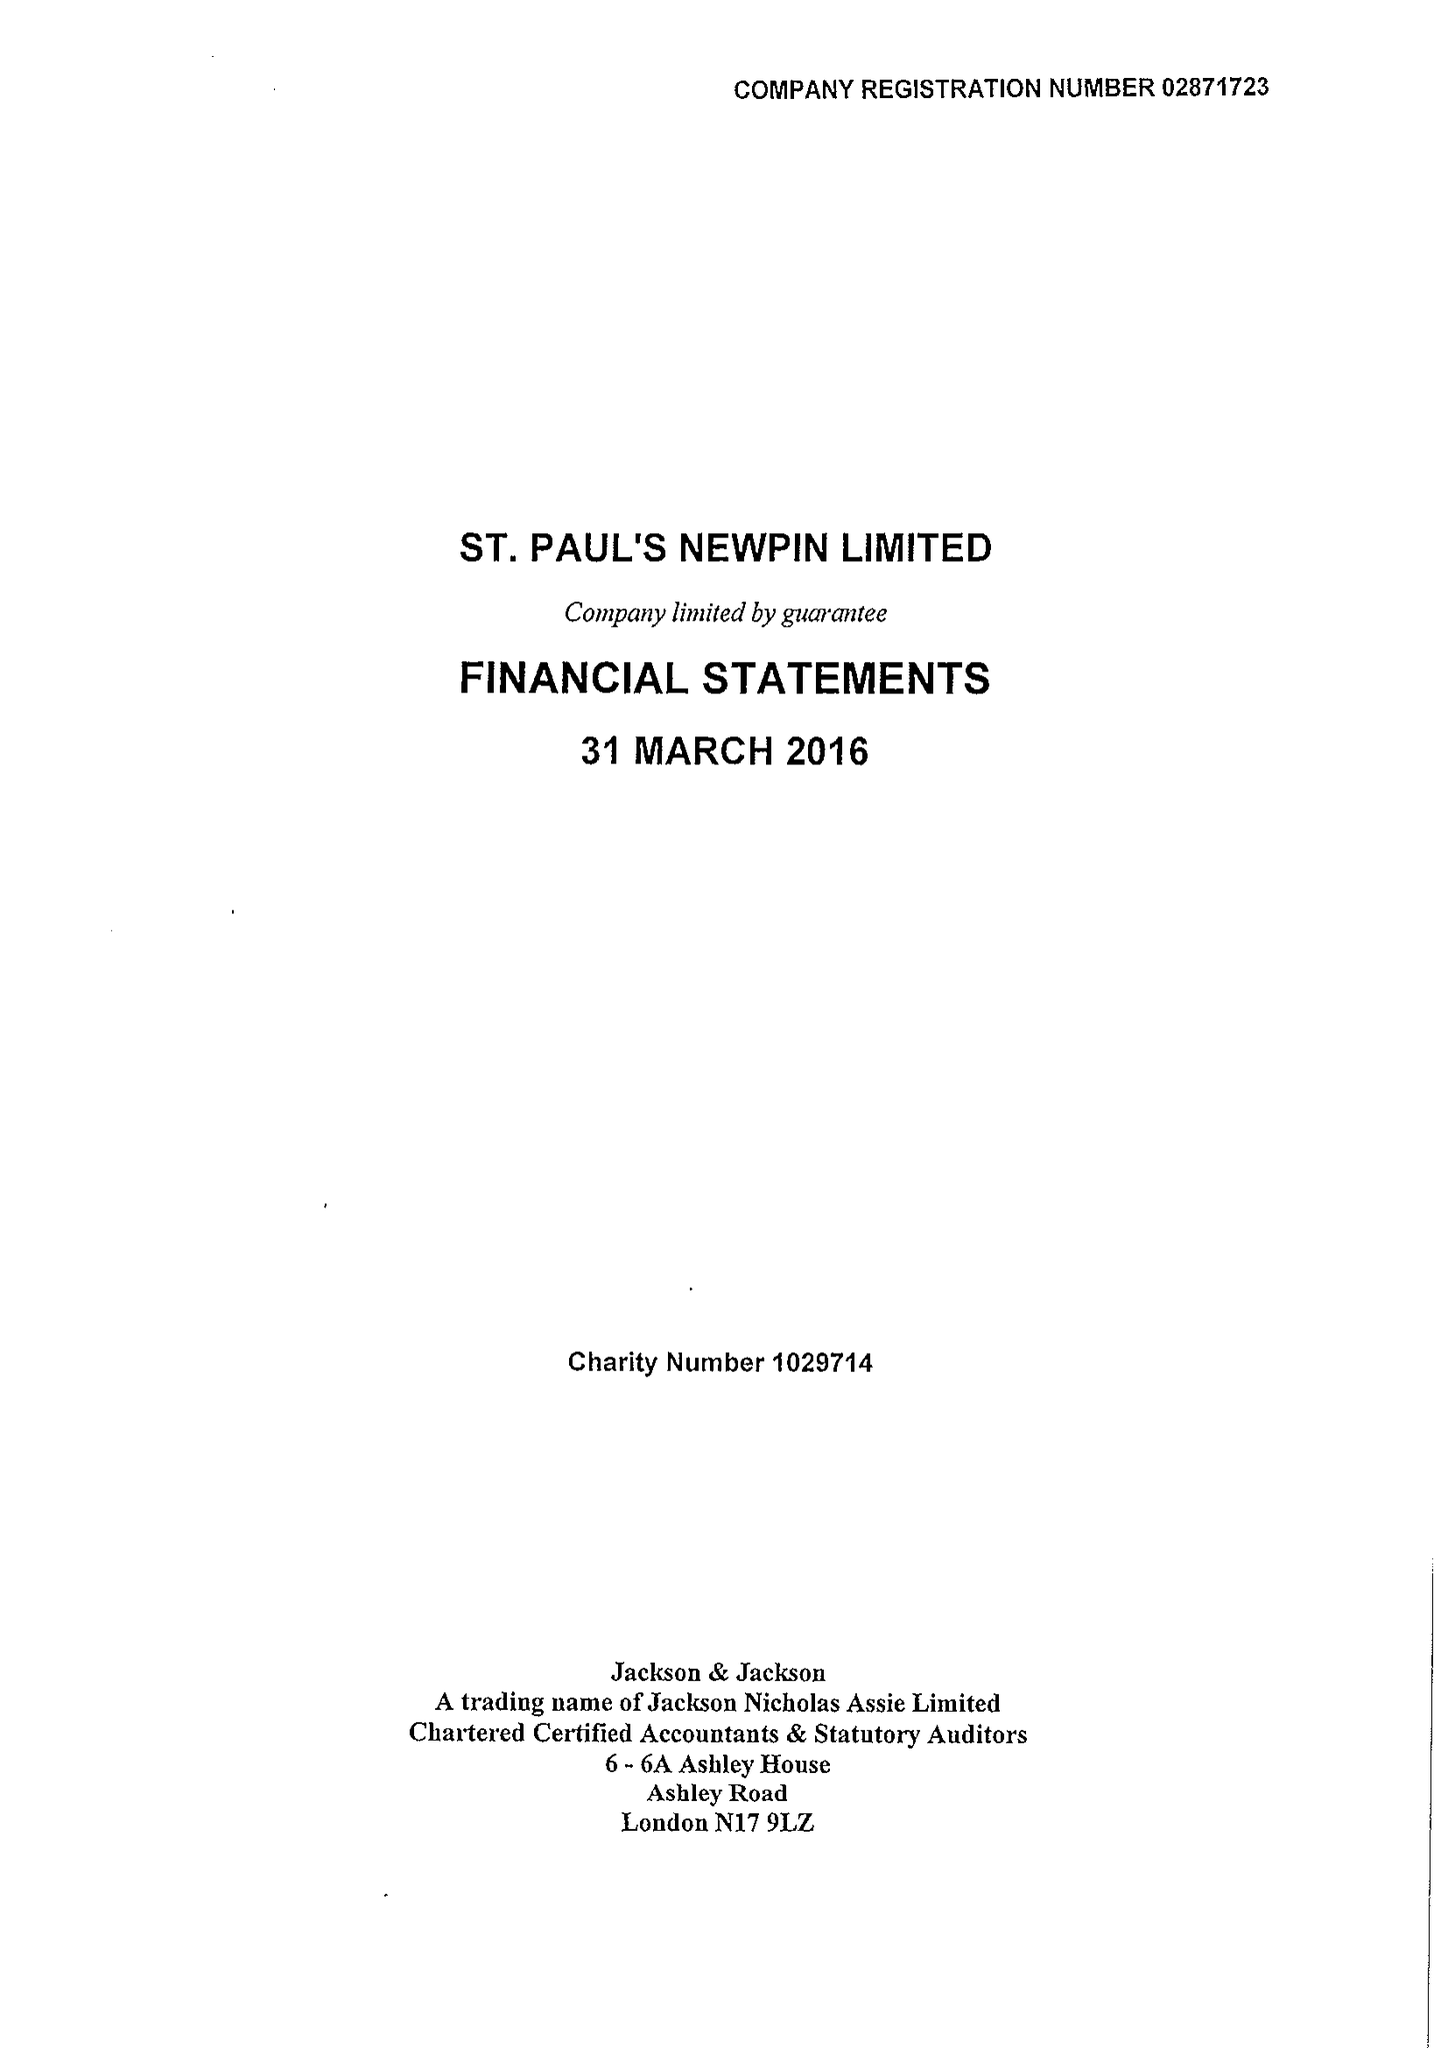What is the value for the address__street_line?
Answer the question using a single word or phrase. GATEFORTH STREET 